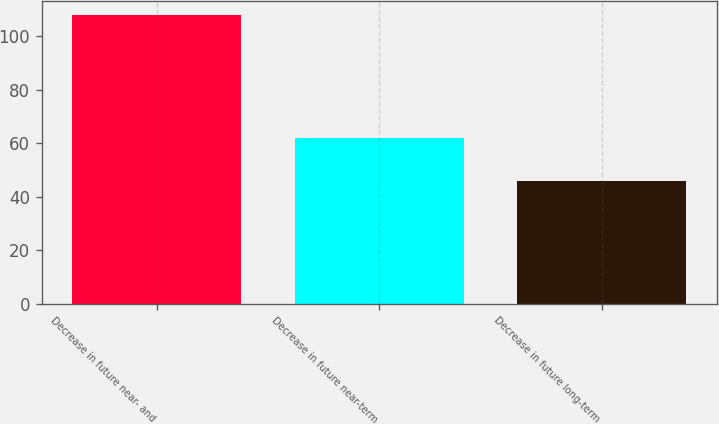<chart> <loc_0><loc_0><loc_500><loc_500><bar_chart><fcel>Decrease in future near- and<fcel>Decrease in future near-term<fcel>Decrease in future long-term<nl><fcel>108<fcel>62<fcel>46<nl></chart> 